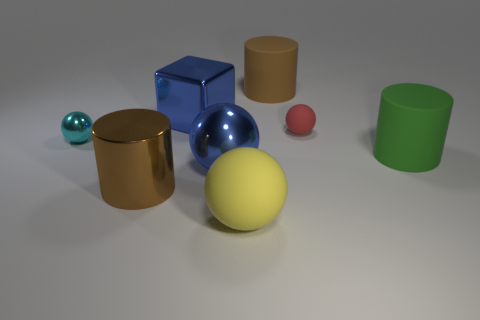How many big blocks have the same color as the small rubber thing?
Keep it short and to the point. 0. There is a large thing that is the same color as the block; what is its material?
Keep it short and to the point. Metal. What is the size of the matte cylinder that is on the left side of the ball to the right of the yellow object?
Ensure brevity in your answer.  Large. Are there any large blue things that have the same material as the yellow thing?
Your response must be concise. No. There is a red object that is the same size as the cyan ball; what is it made of?
Your answer should be compact. Rubber. There is a tiny sphere to the right of the big metal sphere; is its color the same as the thing right of the tiny red rubber sphere?
Provide a short and direct response. No. There is a brown cylinder that is on the right side of the big yellow matte thing; is there a green thing behind it?
Keep it short and to the point. No. There is a big metallic object in front of the blue sphere; is its shape the same as the big object to the right of the large brown matte cylinder?
Your response must be concise. Yes. Are the big sphere on the left side of the large yellow thing and the brown cylinder that is behind the cyan metal sphere made of the same material?
Keep it short and to the point. No. What is the material of the brown cylinder in front of the rubber sphere that is behind the large metallic cylinder?
Provide a succinct answer. Metal. 